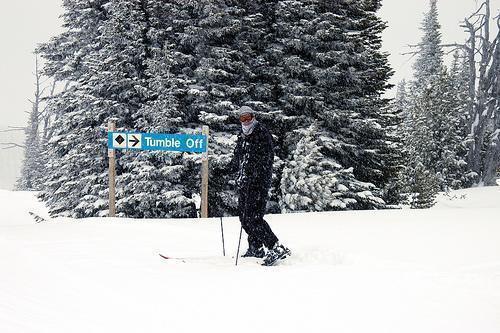How many arrow are on the sign?
Give a very brief answer. 1. How many ski poles does the skier have?
Give a very brief answer. 2. 